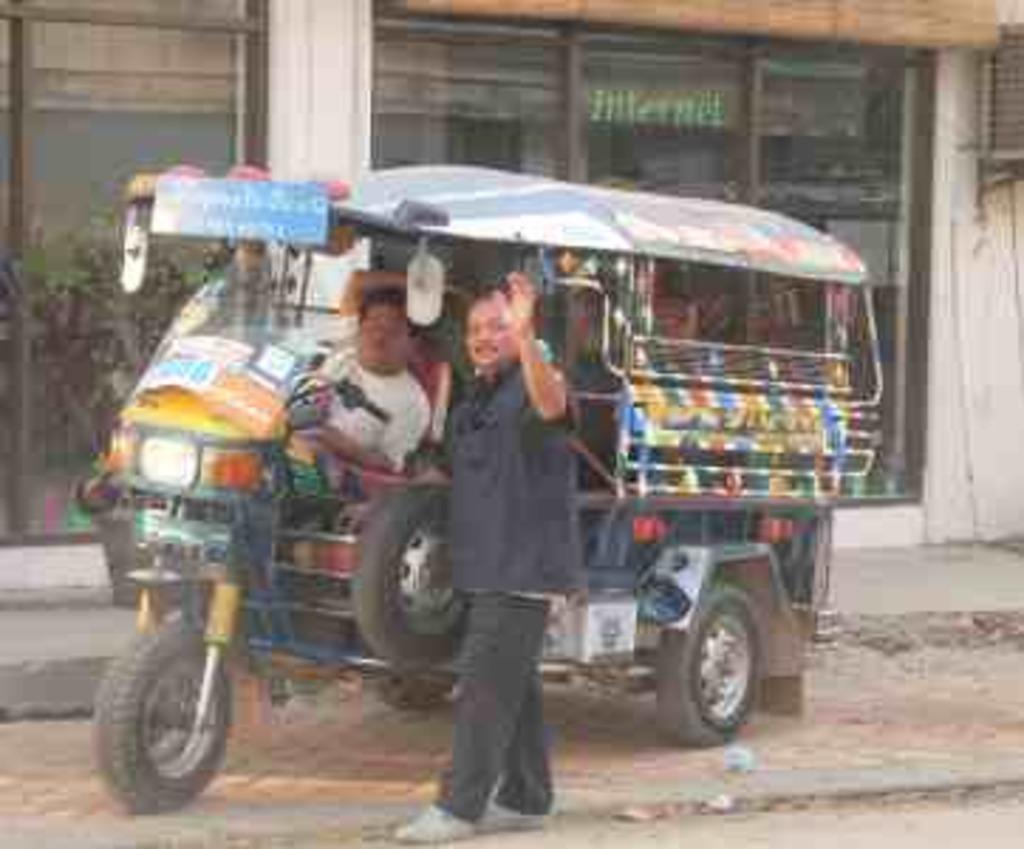In one or two sentences, can you explain what this image depicts? In this image in the center there is a man standing and behind the man there is a vehicle and there is a person sitting inside the vehicle. In the background there is a building and there are glasses. 